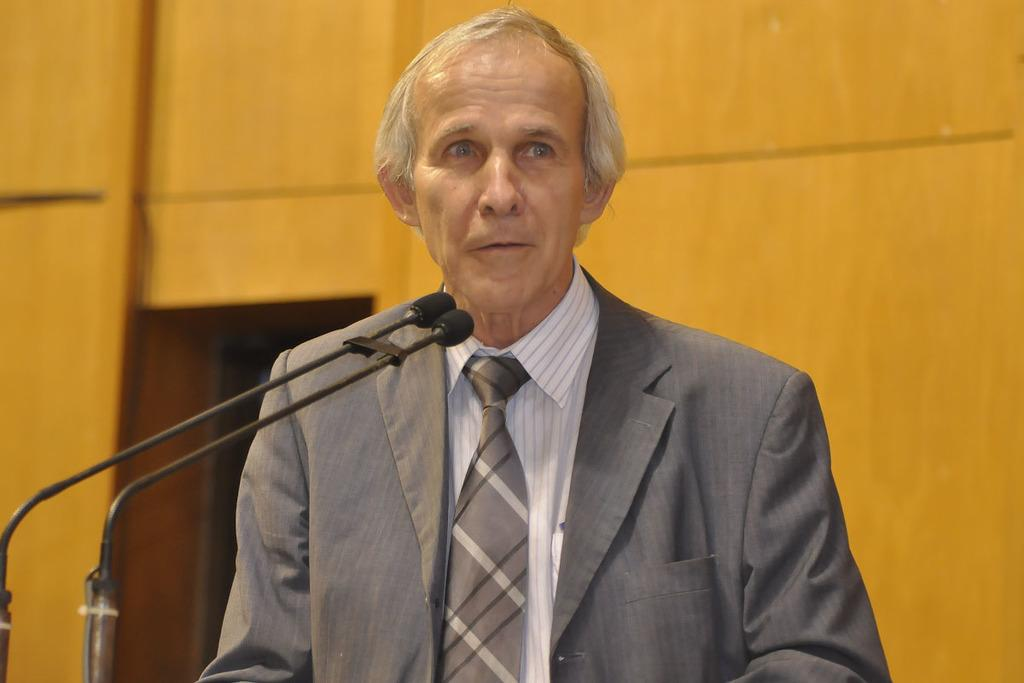Who is present in the image? There is a man in the image. What is the man wearing around his neck? The man is wearing a tie. What objects are in front of the man? There are microphones in front of the man. What can be seen behind the man? There is a wall visible behind the man. What type of glove is the man wearing in the image? The man is not wearing a glove in the image; he is wearing a tie. 